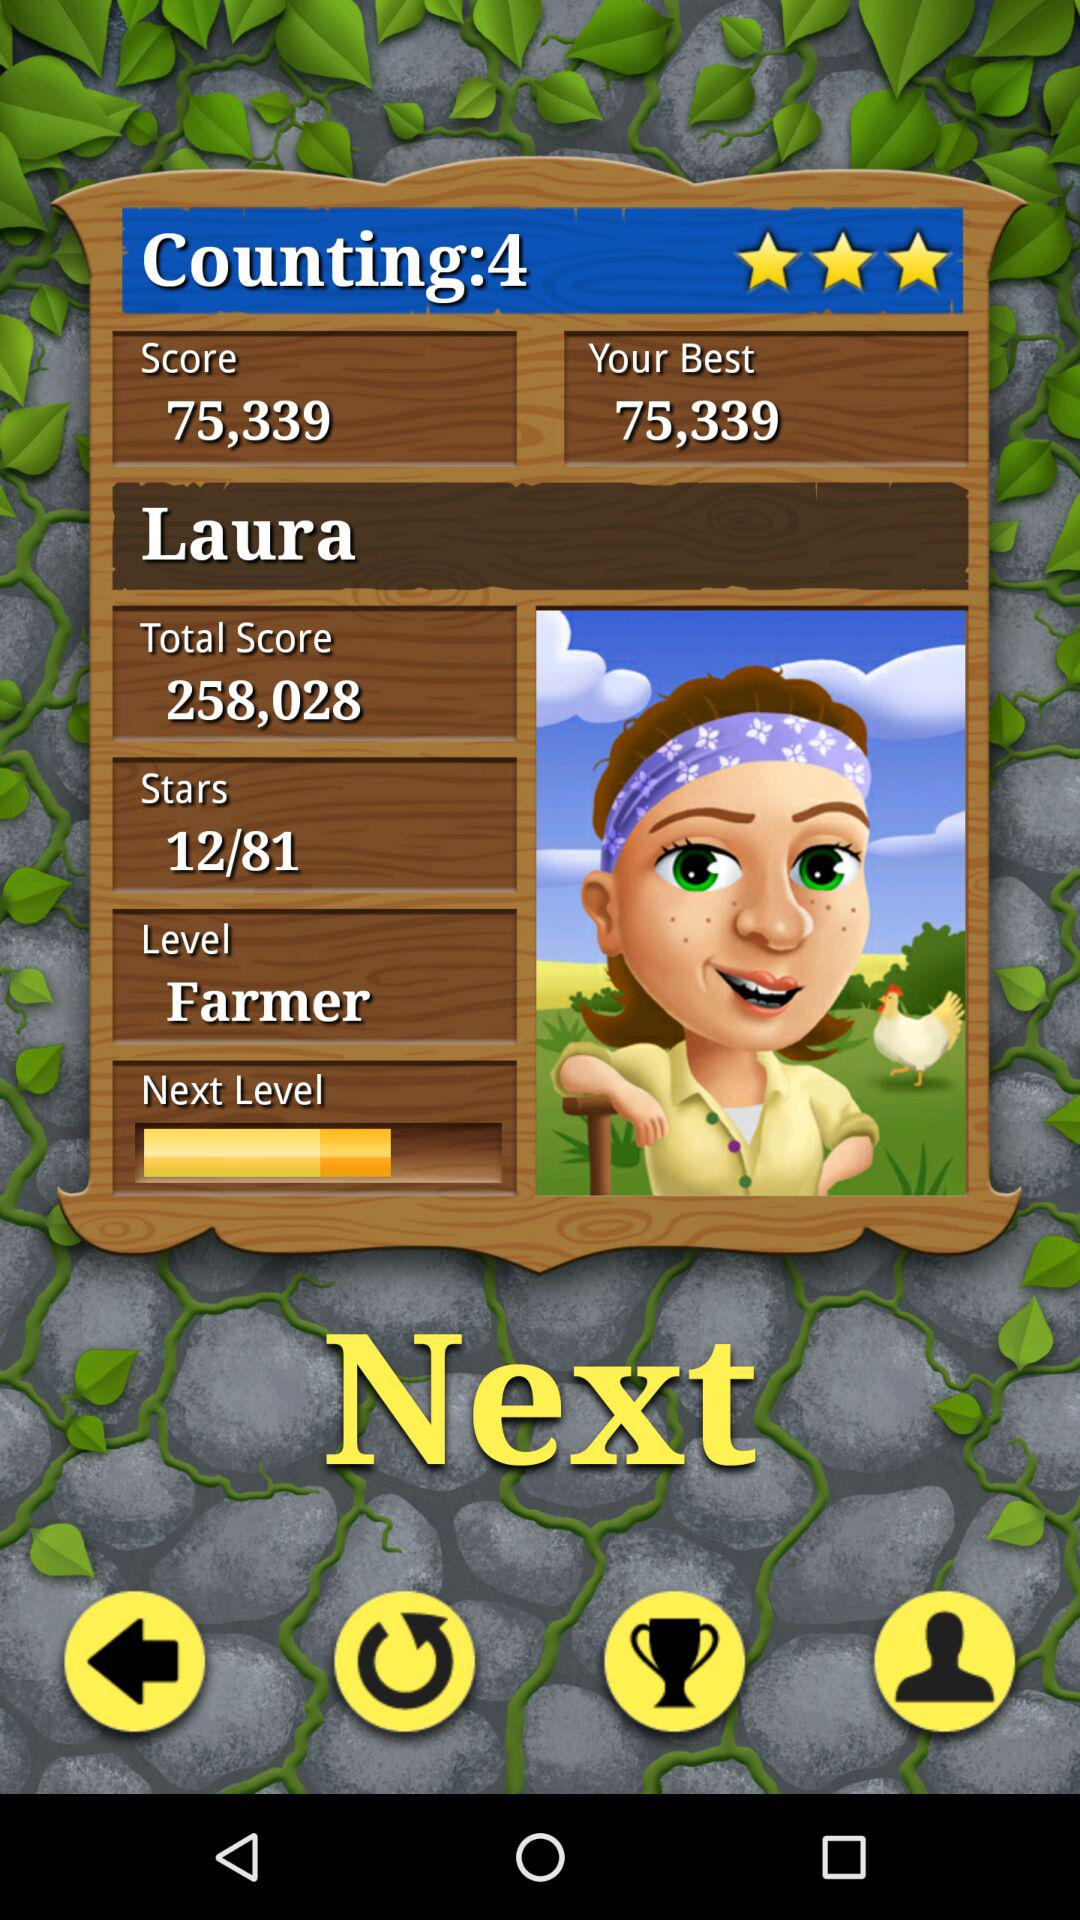What is your best score? Your best score is 75,339. 